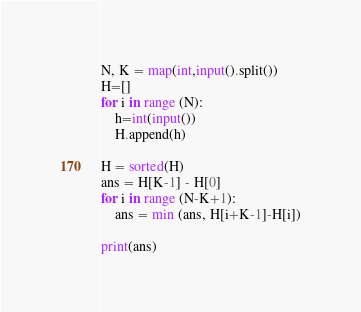<code> <loc_0><loc_0><loc_500><loc_500><_Python_>N, K = map(int,input().split())
H=[]
for i in range (N):
    h=int(input())
    H.append(h)

H = sorted(H)
ans = H[K-1] - H[0]
for i in range (N-K+1):
    ans = min (ans, H[i+K-1]-H[i])

print(ans)</code> 